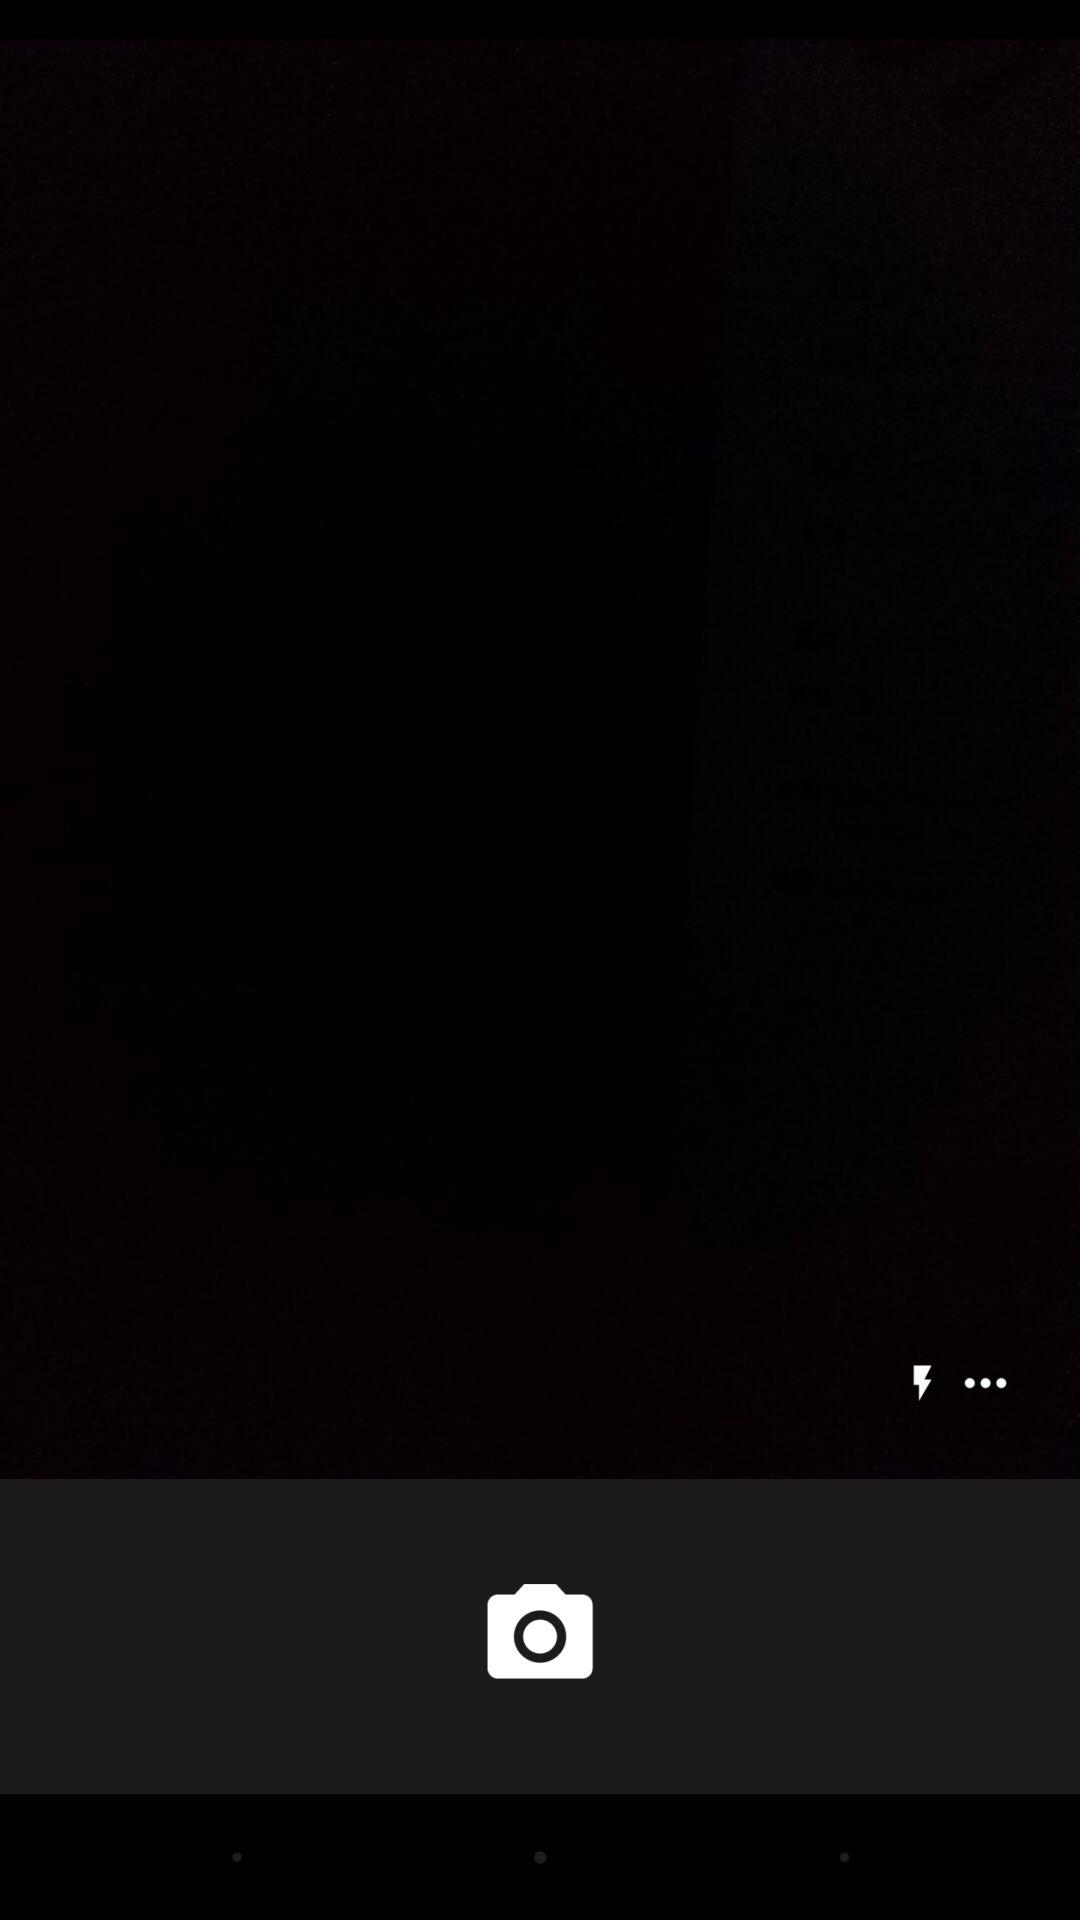How many more dots than lightning bolts are on the screen?
Answer the question using a single word or phrase. 2 